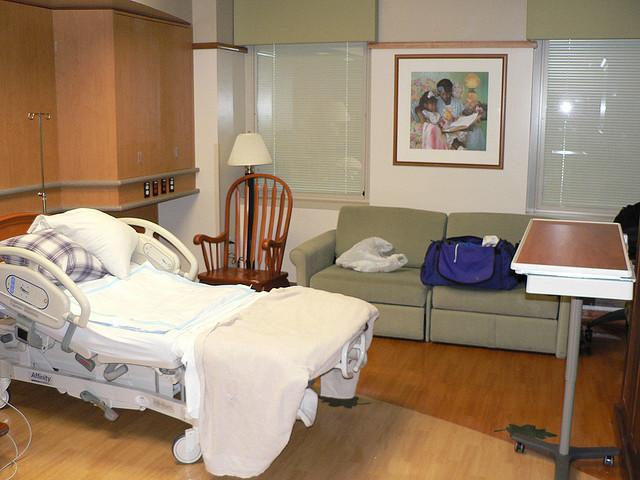Is this a hospital room?
Write a very short answer. Yes. Is the lamp on?
Concise answer only. No. Is there anything plugged into the wall outlets by the chair?
Concise answer only. No. 